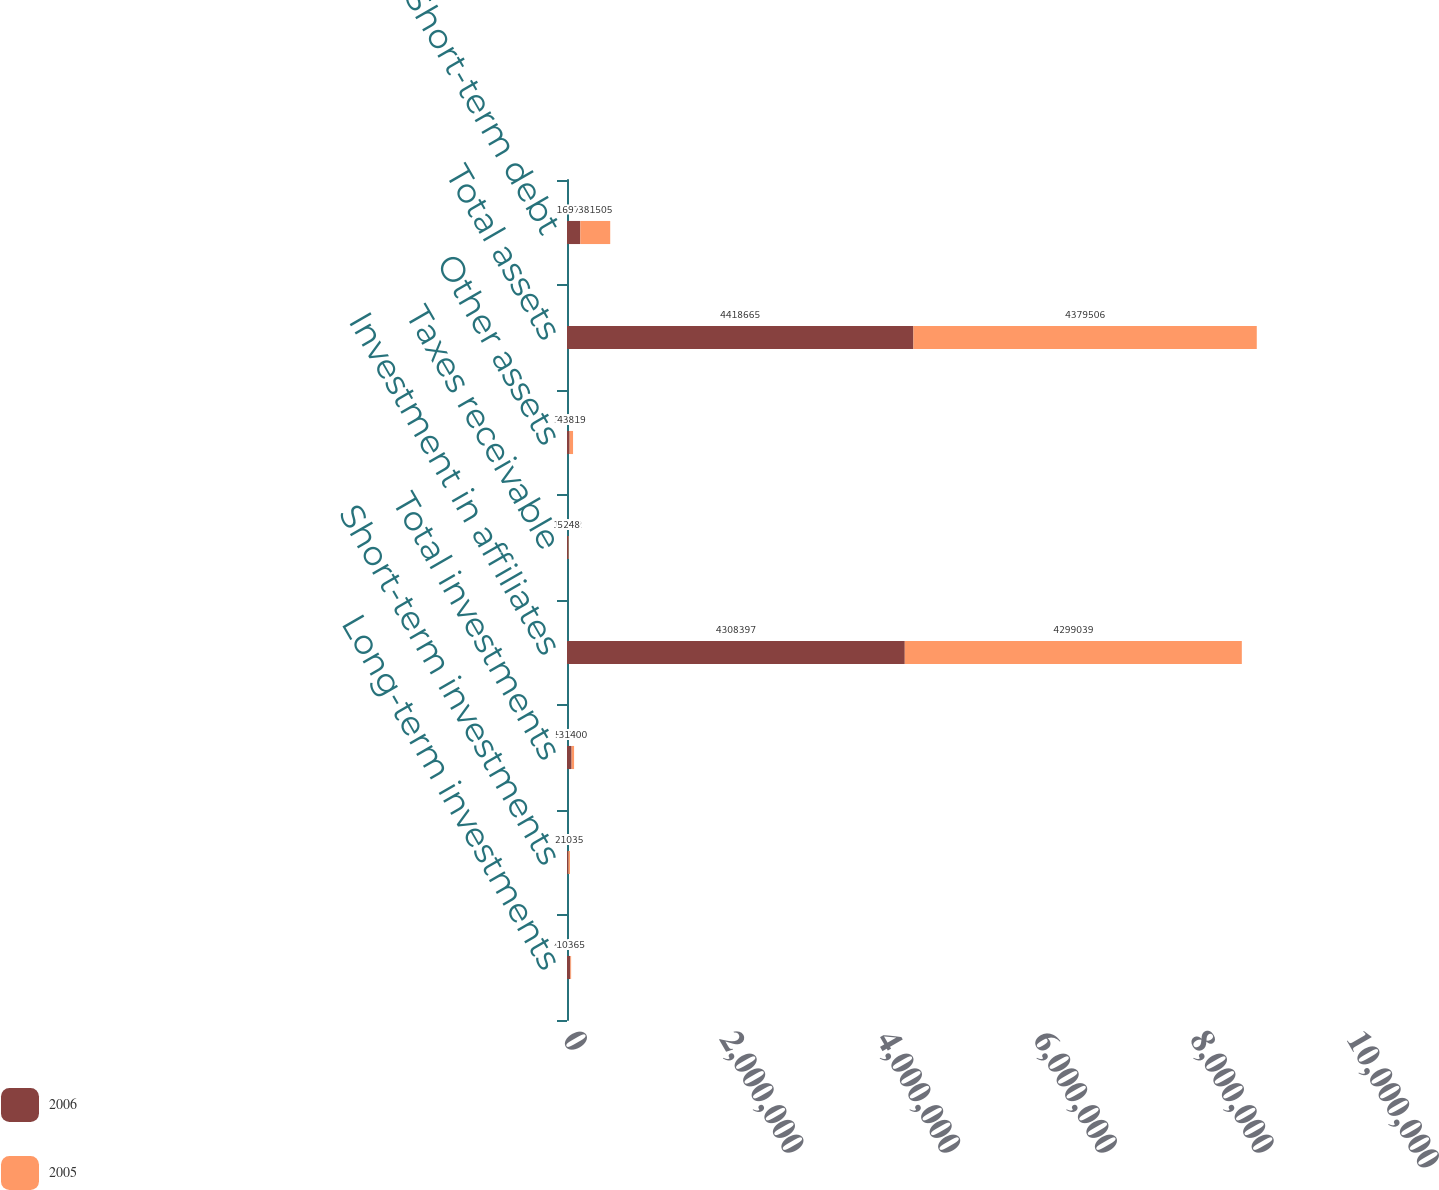<chart> <loc_0><loc_0><loc_500><loc_500><stacked_bar_chart><ecel><fcel>Long-term investments<fcel>Short-term investments<fcel>Total investments<fcel>Investment in affiliates<fcel>Taxes receivable<fcel>Other assets<fcel>Total assets<fcel>Short-term debt<nl><fcel>2006<fcel>42199<fcel>16709<fcel>58908<fcel>4.3084e+06<fcel>18012<fcel>33348<fcel>4.41866e+06<fcel>169736<nl><fcel>2005<fcel>10365<fcel>21035<fcel>31400<fcel>4.29904e+06<fcel>5248<fcel>43819<fcel>4.37951e+06<fcel>381505<nl></chart> 